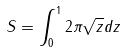<formula> <loc_0><loc_0><loc_500><loc_500>S = \int _ { 0 } ^ { 1 } 2 \pi \sqrt { z } d z</formula> 